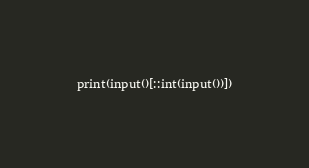Convert code to text. <code><loc_0><loc_0><loc_500><loc_500><_Python_>print(input()[::int(input())])</code> 